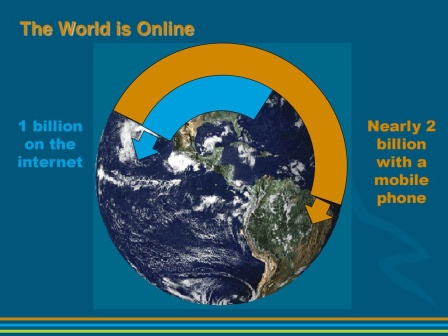What can this image tell us about the growth in technology over the years? This image highlights significant milestones in the expansion of digital technology, particularly focusing on the rapid increase in internet and mobile phone users. It underscores a transformative period in our history where technology has become a fundamental part of daily lives, suggesting a trend of increasing connectivity and technological dependence. 